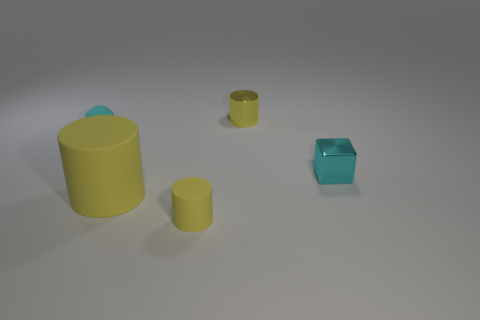What size is the metal cylinder that is the same color as the large thing?
Make the answer very short. Small. There is a rubber thing that is left of the small rubber cylinder and in front of the cyan matte thing; how big is it?
Offer a terse response. Large. Are there any tiny green cubes made of the same material as the large cylinder?
Provide a short and direct response. No. The cyan metal thing has what shape?
Give a very brief answer. Cube. Do the cyan metal block and the yellow metallic cylinder have the same size?
Offer a very short reply. Yes. How many other things are there of the same shape as the tiny cyan metal object?
Offer a terse response. 0. There is a small cyan thing that is in front of the tiny cyan matte ball; what shape is it?
Offer a terse response. Cube. There is a small metallic thing in front of the tiny yellow metallic cylinder; is its shape the same as the small rubber object that is on the right side of the tiny rubber ball?
Ensure brevity in your answer.  No. Are there an equal number of large yellow objects that are right of the yellow metallic cylinder and cyan metal things?
Keep it short and to the point. No. Is there anything else that has the same size as the matte ball?
Keep it short and to the point. Yes. 